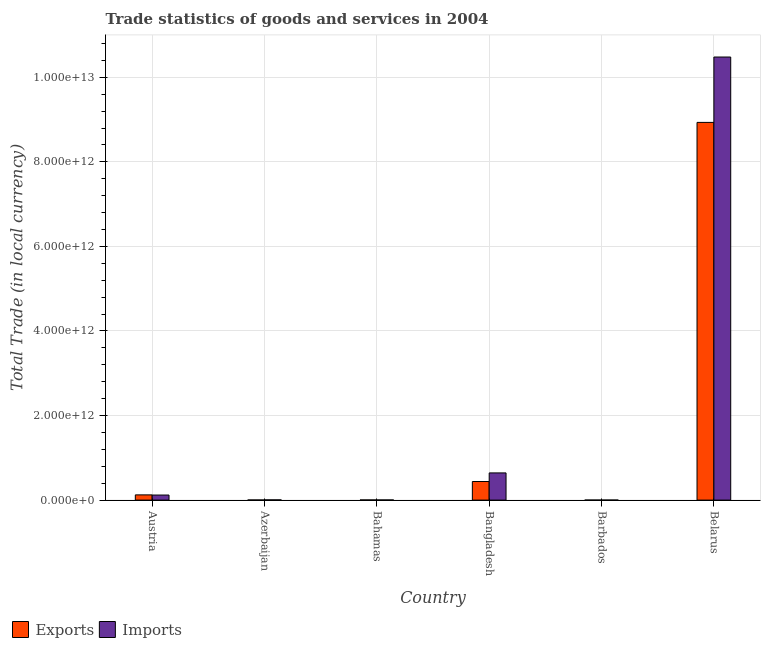How many different coloured bars are there?
Provide a succinct answer. 2. Are the number of bars per tick equal to the number of legend labels?
Offer a very short reply. Yes. Are the number of bars on each tick of the X-axis equal?
Your answer should be compact. Yes. How many bars are there on the 4th tick from the left?
Provide a short and direct response. 2. How many bars are there on the 4th tick from the right?
Make the answer very short. 2. What is the label of the 2nd group of bars from the left?
Offer a terse response. Azerbaijan. What is the imports of goods and services in Austria?
Give a very brief answer. 1.20e+11. Across all countries, what is the maximum imports of goods and services?
Keep it short and to the point. 1.05e+13. Across all countries, what is the minimum imports of goods and services?
Your answer should be very brief. 7.75e+08. In which country was the imports of goods and services maximum?
Offer a terse response. Belarus. In which country was the export of goods and services minimum?
Provide a short and direct response. Barbados. What is the total imports of goods and services in the graph?
Ensure brevity in your answer.  1.13e+13. What is the difference between the imports of goods and services in Bahamas and that in Barbados?
Provide a succinct answer. 2.67e+09. What is the difference between the export of goods and services in Azerbaijan and the imports of goods and services in Austria?
Offer a very short reply. -1.17e+11. What is the average imports of goods and services per country?
Your answer should be very brief. 1.88e+12. What is the difference between the export of goods and services and imports of goods and services in Azerbaijan?
Provide a short and direct response. -2.25e+09. In how many countries, is the imports of goods and services greater than 6000000000000 LCU?
Your answer should be compact. 1. What is the ratio of the export of goods and services in Barbados to that in Belarus?
Your answer should be compact. 7.20890142610876e-5. What is the difference between the highest and the second highest export of goods and services?
Give a very brief answer. 8.49e+12. What is the difference between the highest and the lowest imports of goods and services?
Give a very brief answer. 1.05e+13. In how many countries, is the imports of goods and services greater than the average imports of goods and services taken over all countries?
Offer a terse response. 1. Is the sum of the imports of goods and services in Barbados and Belarus greater than the maximum export of goods and services across all countries?
Offer a very short reply. Yes. What does the 2nd bar from the left in Austria represents?
Your answer should be very brief. Imports. What does the 2nd bar from the right in Bangladesh represents?
Provide a short and direct response. Exports. How many countries are there in the graph?
Your response must be concise. 6. What is the difference between two consecutive major ticks on the Y-axis?
Offer a terse response. 2.00e+12. Does the graph contain grids?
Give a very brief answer. Yes. Where does the legend appear in the graph?
Your answer should be compact. Bottom left. How many legend labels are there?
Your answer should be very brief. 2. How are the legend labels stacked?
Your answer should be compact. Horizontal. What is the title of the graph?
Provide a succinct answer. Trade statistics of goods and services in 2004. Does "From World Bank" appear as one of the legend labels in the graph?
Offer a very short reply. No. What is the label or title of the Y-axis?
Make the answer very short. Total Trade (in local currency). What is the Total Trade (in local currency) of Exports in Austria?
Offer a very short reply. 1.24e+11. What is the Total Trade (in local currency) of Imports in Austria?
Your answer should be compact. 1.20e+11. What is the Total Trade (in local currency) in Exports in Azerbaijan?
Your answer should be very brief. 3.00e+09. What is the Total Trade (in local currency) of Imports in Azerbaijan?
Your response must be concise. 5.25e+09. What is the Total Trade (in local currency) of Exports in Bahamas?
Ensure brevity in your answer.  3.57e+09. What is the Total Trade (in local currency) in Imports in Bahamas?
Provide a succinct answer. 3.44e+09. What is the Total Trade (in local currency) of Exports in Bangladesh?
Keep it short and to the point. 4.40e+11. What is the Total Trade (in local currency) of Imports in Bangladesh?
Keep it short and to the point. 6.43e+11. What is the Total Trade (in local currency) of Exports in Barbados?
Offer a terse response. 6.44e+08. What is the Total Trade (in local currency) of Imports in Barbados?
Your response must be concise. 7.75e+08. What is the Total Trade (in local currency) of Exports in Belarus?
Your answer should be very brief. 8.93e+12. What is the Total Trade (in local currency) of Imports in Belarus?
Provide a succinct answer. 1.05e+13. Across all countries, what is the maximum Total Trade (in local currency) of Exports?
Your answer should be compact. 8.93e+12. Across all countries, what is the maximum Total Trade (in local currency) of Imports?
Your answer should be compact. 1.05e+13. Across all countries, what is the minimum Total Trade (in local currency) of Exports?
Your answer should be very brief. 6.44e+08. Across all countries, what is the minimum Total Trade (in local currency) in Imports?
Your answer should be compact. 7.75e+08. What is the total Total Trade (in local currency) in Exports in the graph?
Make the answer very short. 9.50e+12. What is the total Total Trade (in local currency) of Imports in the graph?
Your response must be concise. 1.13e+13. What is the difference between the Total Trade (in local currency) of Exports in Austria and that in Azerbaijan?
Keep it short and to the point. 1.21e+11. What is the difference between the Total Trade (in local currency) in Imports in Austria and that in Azerbaijan?
Your answer should be compact. 1.15e+11. What is the difference between the Total Trade (in local currency) in Exports in Austria and that in Bahamas?
Ensure brevity in your answer.  1.20e+11. What is the difference between the Total Trade (in local currency) of Imports in Austria and that in Bahamas?
Offer a terse response. 1.16e+11. What is the difference between the Total Trade (in local currency) of Exports in Austria and that in Bangladesh?
Your answer should be very brief. -3.16e+11. What is the difference between the Total Trade (in local currency) in Imports in Austria and that in Bangladesh?
Your response must be concise. -5.23e+11. What is the difference between the Total Trade (in local currency) in Exports in Austria and that in Barbados?
Keep it short and to the point. 1.23e+11. What is the difference between the Total Trade (in local currency) in Imports in Austria and that in Barbados?
Make the answer very short. 1.19e+11. What is the difference between the Total Trade (in local currency) in Exports in Austria and that in Belarus?
Make the answer very short. -8.81e+12. What is the difference between the Total Trade (in local currency) in Imports in Austria and that in Belarus?
Provide a short and direct response. -1.04e+13. What is the difference between the Total Trade (in local currency) of Exports in Azerbaijan and that in Bahamas?
Keep it short and to the point. -5.69e+08. What is the difference between the Total Trade (in local currency) in Imports in Azerbaijan and that in Bahamas?
Your answer should be compact. 1.80e+09. What is the difference between the Total Trade (in local currency) in Exports in Azerbaijan and that in Bangladesh?
Keep it short and to the point. -4.37e+11. What is the difference between the Total Trade (in local currency) in Imports in Azerbaijan and that in Bangladesh?
Offer a very short reply. -6.38e+11. What is the difference between the Total Trade (in local currency) of Exports in Azerbaijan and that in Barbados?
Ensure brevity in your answer.  2.35e+09. What is the difference between the Total Trade (in local currency) in Imports in Azerbaijan and that in Barbados?
Provide a short and direct response. 4.47e+09. What is the difference between the Total Trade (in local currency) of Exports in Azerbaijan and that in Belarus?
Provide a succinct answer. -8.93e+12. What is the difference between the Total Trade (in local currency) in Imports in Azerbaijan and that in Belarus?
Keep it short and to the point. -1.05e+13. What is the difference between the Total Trade (in local currency) of Exports in Bahamas and that in Bangladesh?
Your answer should be compact. -4.36e+11. What is the difference between the Total Trade (in local currency) of Imports in Bahamas and that in Bangladesh?
Ensure brevity in your answer.  -6.40e+11. What is the difference between the Total Trade (in local currency) in Exports in Bahamas and that in Barbados?
Ensure brevity in your answer.  2.92e+09. What is the difference between the Total Trade (in local currency) in Imports in Bahamas and that in Barbados?
Provide a succinct answer. 2.67e+09. What is the difference between the Total Trade (in local currency) of Exports in Bahamas and that in Belarus?
Your response must be concise. -8.93e+12. What is the difference between the Total Trade (in local currency) in Imports in Bahamas and that in Belarus?
Offer a very short reply. -1.05e+13. What is the difference between the Total Trade (in local currency) of Exports in Bangladesh and that in Barbados?
Offer a terse response. 4.39e+11. What is the difference between the Total Trade (in local currency) of Imports in Bangladesh and that in Barbados?
Ensure brevity in your answer.  6.42e+11. What is the difference between the Total Trade (in local currency) in Exports in Bangladesh and that in Belarus?
Your answer should be compact. -8.49e+12. What is the difference between the Total Trade (in local currency) of Imports in Bangladesh and that in Belarus?
Offer a very short reply. -9.84e+12. What is the difference between the Total Trade (in local currency) in Exports in Barbados and that in Belarus?
Your answer should be very brief. -8.93e+12. What is the difference between the Total Trade (in local currency) of Imports in Barbados and that in Belarus?
Ensure brevity in your answer.  -1.05e+13. What is the difference between the Total Trade (in local currency) in Exports in Austria and the Total Trade (in local currency) in Imports in Azerbaijan?
Offer a very short reply. 1.18e+11. What is the difference between the Total Trade (in local currency) in Exports in Austria and the Total Trade (in local currency) in Imports in Bahamas?
Your answer should be compact. 1.20e+11. What is the difference between the Total Trade (in local currency) of Exports in Austria and the Total Trade (in local currency) of Imports in Bangladesh?
Ensure brevity in your answer.  -5.20e+11. What is the difference between the Total Trade (in local currency) in Exports in Austria and the Total Trade (in local currency) in Imports in Barbados?
Your response must be concise. 1.23e+11. What is the difference between the Total Trade (in local currency) in Exports in Austria and the Total Trade (in local currency) in Imports in Belarus?
Provide a short and direct response. -1.04e+13. What is the difference between the Total Trade (in local currency) of Exports in Azerbaijan and the Total Trade (in local currency) of Imports in Bahamas?
Offer a terse response. -4.48e+08. What is the difference between the Total Trade (in local currency) in Exports in Azerbaijan and the Total Trade (in local currency) in Imports in Bangladesh?
Make the answer very short. -6.40e+11. What is the difference between the Total Trade (in local currency) in Exports in Azerbaijan and the Total Trade (in local currency) in Imports in Barbados?
Provide a succinct answer. 2.22e+09. What is the difference between the Total Trade (in local currency) of Exports in Azerbaijan and the Total Trade (in local currency) of Imports in Belarus?
Make the answer very short. -1.05e+13. What is the difference between the Total Trade (in local currency) in Exports in Bahamas and the Total Trade (in local currency) in Imports in Bangladesh?
Ensure brevity in your answer.  -6.40e+11. What is the difference between the Total Trade (in local currency) of Exports in Bahamas and the Total Trade (in local currency) of Imports in Barbados?
Offer a very short reply. 2.79e+09. What is the difference between the Total Trade (in local currency) in Exports in Bahamas and the Total Trade (in local currency) in Imports in Belarus?
Provide a succinct answer. -1.05e+13. What is the difference between the Total Trade (in local currency) in Exports in Bangladesh and the Total Trade (in local currency) in Imports in Barbados?
Make the answer very short. 4.39e+11. What is the difference between the Total Trade (in local currency) in Exports in Bangladesh and the Total Trade (in local currency) in Imports in Belarus?
Offer a terse response. -1.00e+13. What is the difference between the Total Trade (in local currency) of Exports in Barbados and the Total Trade (in local currency) of Imports in Belarus?
Provide a short and direct response. -1.05e+13. What is the average Total Trade (in local currency) in Exports per country?
Ensure brevity in your answer.  1.58e+12. What is the average Total Trade (in local currency) of Imports per country?
Your answer should be very brief. 1.88e+12. What is the difference between the Total Trade (in local currency) in Exports and Total Trade (in local currency) in Imports in Austria?
Keep it short and to the point. 3.74e+09. What is the difference between the Total Trade (in local currency) of Exports and Total Trade (in local currency) of Imports in Azerbaijan?
Your answer should be compact. -2.25e+09. What is the difference between the Total Trade (in local currency) in Exports and Total Trade (in local currency) in Imports in Bahamas?
Your response must be concise. 1.21e+08. What is the difference between the Total Trade (in local currency) in Exports and Total Trade (in local currency) in Imports in Bangladesh?
Make the answer very short. -2.04e+11. What is the difference between the Total Trade (in local currency) of Exports and Total Trade (in local currency) of Imports in Barbados?
Make the answer very short. -1.31e+08. What is the difference between the Total Trade (in local currency) of Exports and Total Trade (in local currency) of Imports in Belarus?
Your answer should be very brief. -1.55e+12. What is the ratio of the Total Trade (in local currency) of Exports in Austria to that in Azerbaijan?
Your answer should be very brief. 41.23. What is the ratio of the Total Trade (in local currency) of Imports in Austria to that in Azerbaijan?
Offer a very short reply. 22.84. What is the ratio of the Total Trade (in local currency) in Exports in Austria to that in Bahamas?
Offer a terse response. 34.65. What is the ratio of the Total Trade (in local currency) of Imports in Austria to that in Bahamas?
Provide a succinct answer. 34.78. What is the ratio of the Total Trade (in local currency) in Exports in Austria to that in Bangladesh?
Offer a terse response. 0.28. What is the ratio of the Total Trade (in local currency) of Imports in Austria to that in Bangladesh?
Provide a succinct answer. 0.19. What is the ratio of the Total Trade (in local currency) in Exports in Austria to that in Barbados?
Ensure brevity in your answer.  191.88. What is the ratio of the Total Trade (in local currency) of Imports in Austria to that in Barbados?
Keep it short and to the point. 154.61. What is the ratio of the Total Trade (in local currency) of Exports in Austria to that in Belarus?
Your answer should be very brief. 0.01. What is the ratio of the Total Trade (in local currency) of Imports in Austria to that in Belarus?
Offer a very short reply. 0.01. What is the ratio of the Total Trade (in local currency) in Exports in Azerbaijan to that in Bahamas?
Offer a terse response. 0.84. What is the ratio of the Total Trade (in local currency) in Imports in Azerbaijan to that in Bahamas?
Your response must be concise. 1.52. What is the ratio of the Total Trade (in local currency) of Exports in Azerbaijan to that in Bangladesh?
Offer a terse response. 0.01. What is the ratio of the Total Trade (in local currency) in Imports in Azerbaijan to that in Bangladesh?
Provide a short and direct response. 0.01. What is the ratio of the Total Trade (in local currency) in Exports in Azerbaijan to that in Barbados?
Make the answer very short. 4.65. What is the ratio of the Total Trade (in local currency) of Imports in Azerbaijan to that in Barbados?
Provide a short and direct response. 6.77. What is the ratio of the Total Trade (in local currency) of Exports in Azerbaijan to that in Belarus?
Ensure brevity in your answer.  0. What is the ratio of the Total Trade (in local currency) of Imports in Azerbaijan to that in Belarus?
Your response must be concise. 0. What is the ratio of the Total Trade (in local currency) in Exports in Bahamas to that in Bangladesh?
Your answer should be very brief. 0.01. What is the ratio of the Total Trade (in local currency) in Imports in Bahamas to that in Bangladesh?
Give a very brief answer. 0.01. What is the ratio of the Total Trade (in local currency) of Exports in Bahamas to that in Barbados?
Give a very brief answer. 5.54. What is the ratio of the Total Trade (in local currency) in Imports in Bahamas to that in Barbados?
Provide a short and direct response. 4.44. What is the ratio of the Total Trade (in local currency) in Exports in Bahamas to that in Belarus?
Ensure brevity in your answer.  0. What is the ratio of the Total Trade (in local currency) of Exports in Bangladesh to that in Barbados?
Your answer should be compact. 682.61. What is the ratio of the Total Trade (in local currency) in Imports in Bangladesh to that in Barbados?
Offer a terse response. 829.89. What is the ratio of the Total Trade (in local currency) in Exports in Bangladesh to that in Belarus?
Offer a very short reply. 0.05. What is the ratio of the Total Trade (in local currency) of Imports in Bangladesh to that in Belarus?
Make the answer very short. 0.06. What is the ratio of the Total Trade (in local currency) of Imports in Barbados to that in Belarus?
Your answer should be compact. 0. What is the difference between the highest and the second highest Total Trade (in local currency) in Exports?
Your response must be concise. 8.49e+12. What is the difference between the highest and the second highest Total Trade (in local currency) of Imports?
Provide a succinct answer. 9.84e+12. What is the difference between the highest and the lowest Total Trade (in local currency) in Exports?
Provide a short and direct response. 8.93e+12. What is the difference between the highest and the lowest Total Trade (in local currency) of Imports?
Ensure brevity in your answer.  1.05e+13. 